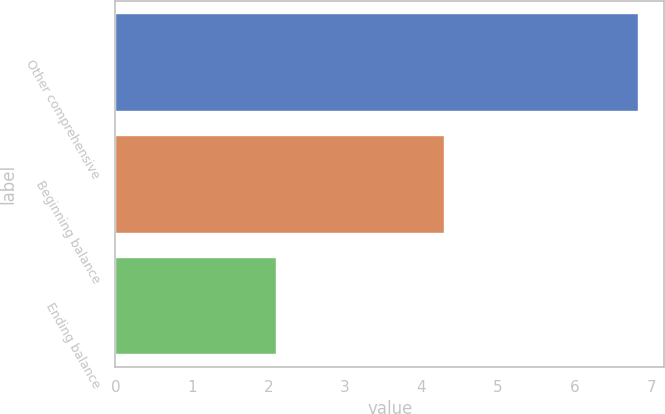<chart> <loc_0><loc_0><loc_500><loc_500><bar_chart><fcel>Other comprehensive<fcel>Beginning balance<fcel>Ending balance<nl><fcel>6.83<fcel>4.3<fcel>2.1<nl></chart> 